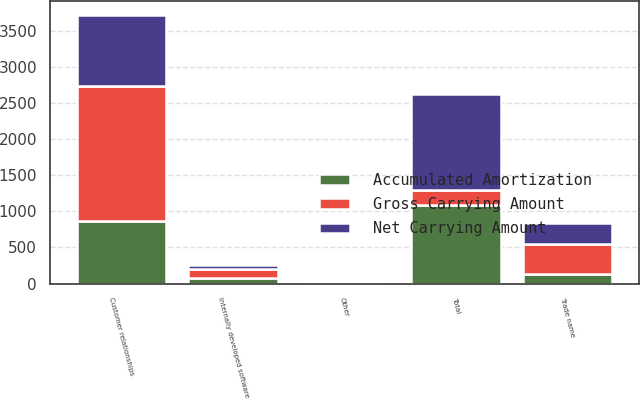<chart> <loc_0><loc_0><loc_500><loc_500><stacked_bar_chart><ecel><fcel>Customer relationships<fcel>Trade name<fcel>Internally developed software<fcel>Other<fcel>Total<nl><fcel>Gross Carrying Amount<fcel>1860.8<fcel>421<fcel>128.5<fcel>3.1<fcel>210.5<nl><fcel>Accumulated Amortization<fcel>872.8<fcel>130.9<fcel>79.8<fcel>1.9<fcel>1085.4<nl><fcel>Net Carrying Amount<fcel>988<fcel>290.1<fcel>48.7<fcel>1.2<fcel>1328<nl></chart> 